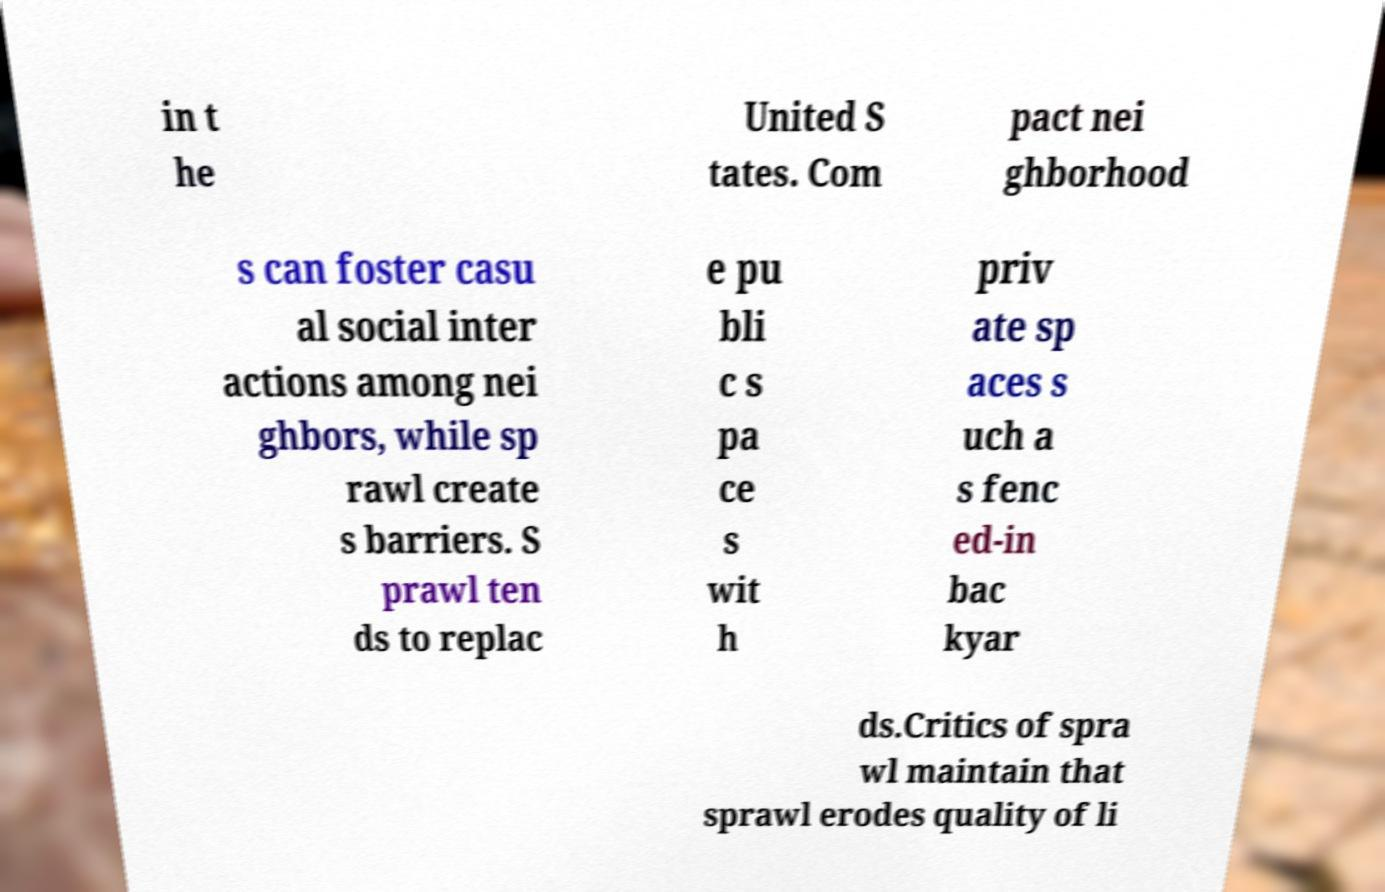Can you read and provide the text displayed in the image?This photo seems to have some interesting text. Can you extract and type it out for me? in t he United S tates. Com pact nei ghborhood s can foster casu al social inter actions among nei ghbors, while sp rawl create s barriers. S prawl ten ds to replac e pu bli c s pa ce s wit h priv ate sp aces s uch a s fenc ed-in bac kyar ds.Critics of spra wl maintain that sprawl erodes quality of li 